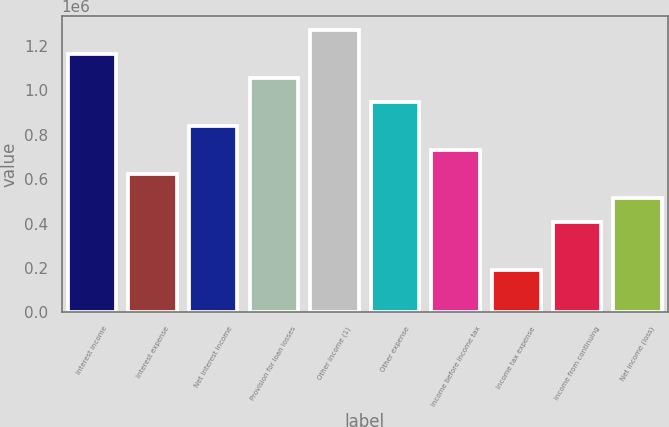Convert chart. <chart><loc_0><loc_0><loc_500><loc_500><bar_chart><fcel>Interest income<fcel>Interest expense<fcel>Net interest income<fcel>Provision for loan losses<fcel>Other income (1)<fcel>Other expense<fcel>Income before income tax<fcel>Income tax expense<fcel>Income from continuing<fcel>Net income (loss)<nl><fcel>1.16182e+06<fcel>621258<fcel>837482<fcel>1.05371e+06<fcel>1.26993e+06<fcel>945594<fcel>729370<fcel>188810<fcel>405034<fcel>513146<nl></chart> 